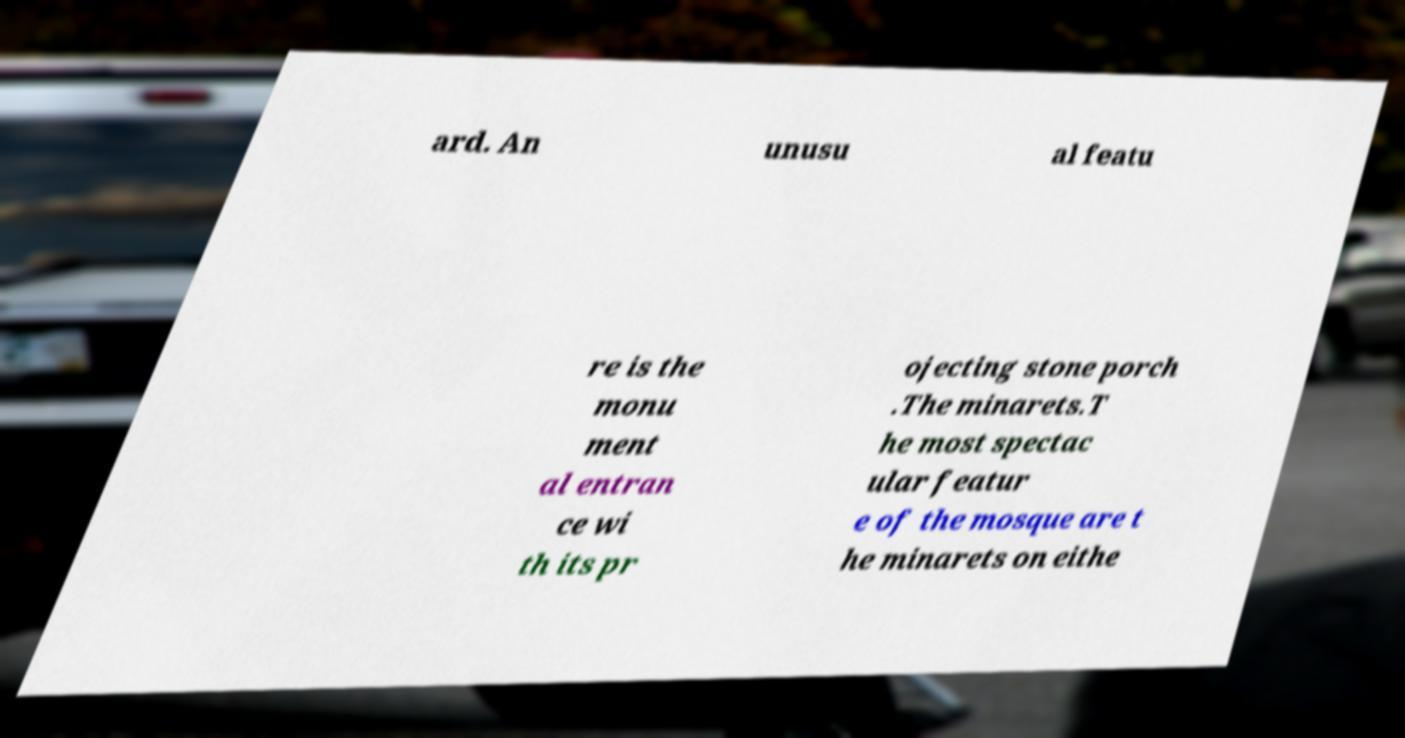Could you assist in decoding the text presented in this image and type it out clearly? ard. An unusu al featu re is the monu ment al entran ce wi th its pr ojecting stone porch .The minarets.T he most spectac ular featur e of the mosque are t he minarets on eithe 